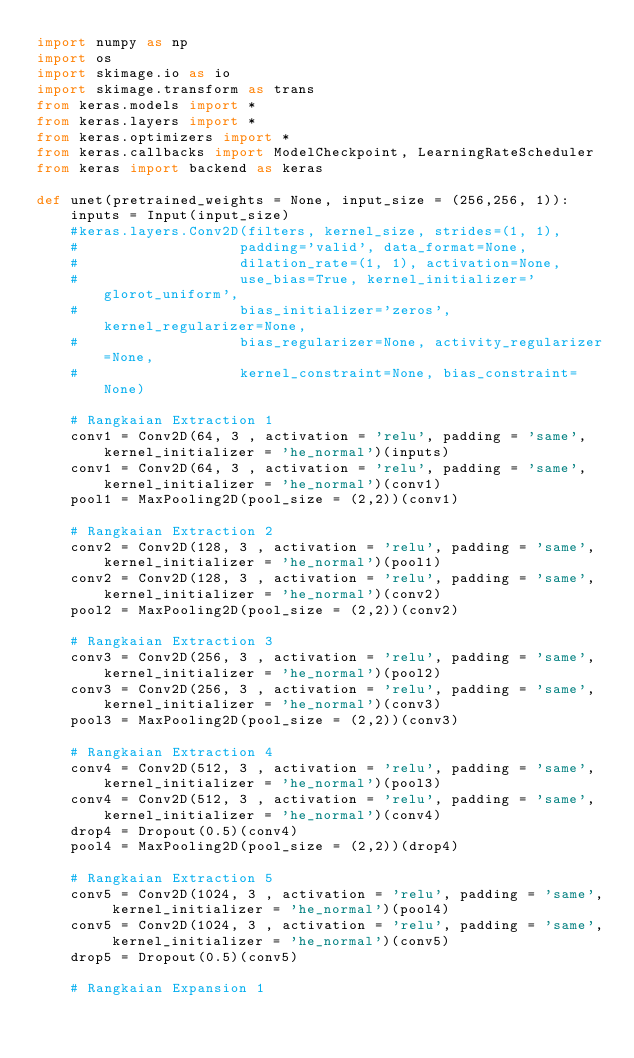Convert code to text. <code><loc_0><loc_0><loc_500><loc_500><_Python_>import numpy as np 
import os 
import skimage.io as io 
import skimage.transform as trans 
from keras.models import *
from keras.layers import *
from keras.optimizers import *
from keras.callbacks import ModelCheckpoint, LearningRateScheduler
from keras import backend as keras

def unet(pretrained_weights = None, input_size = (256,256, 1)):
    inputs = Input(input_size)
    #keras.layers.Conv2D(filters, kernel_size, strides=(1, 1), 
    #                   padding='valid', data_format=None, 
    #                   dilation_rate=(1, 1), activation=None, 
    #                   use_bias=True, kernel_initializer='glorot_uniform', 
    #                   bias_initializer='zeros', kernel_regularizer=None, 
    #                   bias_regularizer=None, activity_regularizer=None, 
    #                   kernel_constraint=None, bias_constraint=None)
    
    # Rangkaian Extraction 1
    conv1 = Conv2D(64, 3 , activation = 'relu', padding = 'same', kernel_initializer = 'he_normal')(inputs)
    conv1 = Conv2D(64, 3 , activation = 'relu', padding = 'same', kernel_initializer = 'he_normal')(conv1)
    pool1 = MaxPooling2D(pool_size = (2,2))(conv1)

    # Rangkaian Extraction 2
    conv2 = Conv2D(128, 3 , activation = 'relu', padding = 'same', kernel_initializer = 'he_normal')(pool1)
    conv2 = Conv2D(128, 3 , activation = 'relu', padding = 'same', kernel_initializer = 'he_normal')(conv2)
    pool2 = MaxPooling2D(pool_size = (2,2))(conv2)

    # Rangkaian Extraction 3
    conv3 = Conv2D(256, 3 , activation = 'relu', padding = 'same', kernel_initializer = 'he_normal')(pool2)
    conv3 = Conv2D(256, 3 , activation = 'relu', padding = 'same', kernel_initializer = 'he_normal')(conv3)
    pool3 = MaxPooling2D(pool_size = (2,2))(conv3)

    # Rangkaian Extraction 4
    conv4 = Conv2D(512, 3 , activation = 'relu', padding = 'same', kernel_initializer = 'he_normal')(pool3)
    conv4 = Conv2D(512, 3 , activation = 'relu', padding = 'same', kernel_initializer = 'he_normal')(conv4)
    drop4 = Dropout(0.5)(conv4)
    pool4 = MaxPooling2D(pool_size = (2,2))(drop4)

    # Rangkaian Extraction 5
    conv5 = Conv2D(1024, 3 , activation = 'relu', padding = 'same', kernel_initializer = 'he_normal')(pool4)
    conv5 = Conv2D(1024, 3 , activation = 'relu', padding = 'same', kernel_initializer = 'he_normal')(conv5)
    drop5 = Dropout(0.5)(conv5)

    # Rangkaian Expansion 1</code> 